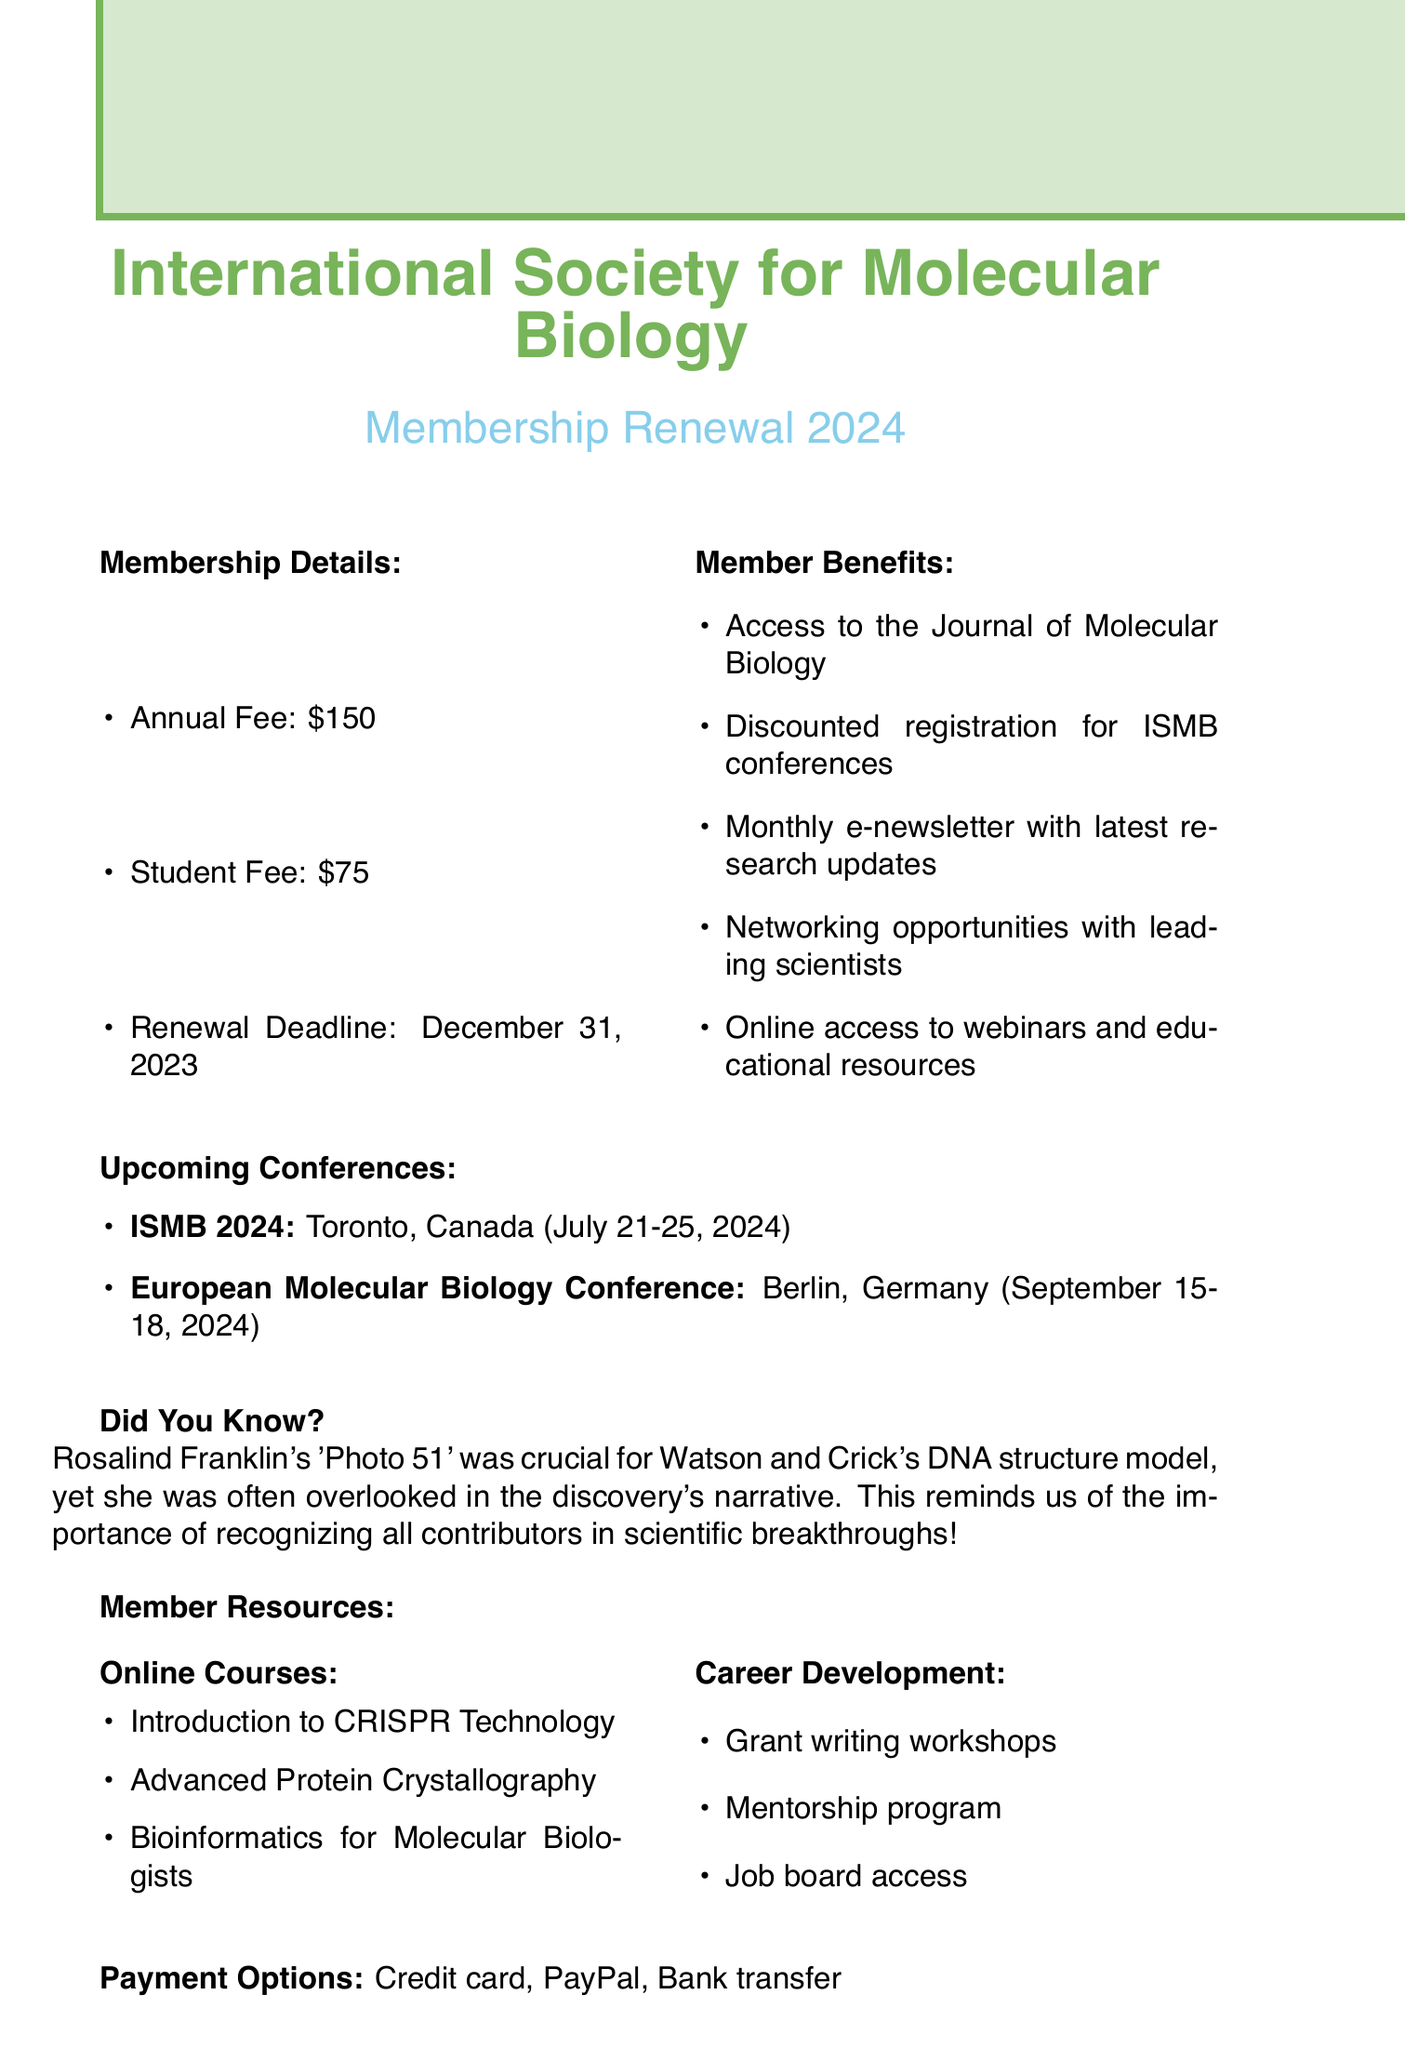What is the annual membership fee? The document states the annual fee for membership is clearly indicated in the membership details section.
Answer: $150 What is the student membership fee? The document specifies the student fee in the membership details.
Answer: $75 What is the renewal deadline for membership? The renewal deadline is explicitly mentioned in the membership details section of the document.
Answer: December 31, 2023 Who is the keynote speaker for ISMB 2024? The document includes the keynote speaker's name for the ISMB 2024 conference in the upcoming conferences section.
Answer: Dr. Jennifer Doudna Where is the European Molecular Biology Conference being held? The document provides the location for the European Molecular Biology Conference in the upcoming conferences section.
Answer: Berlin, Germany What benefit includes access to latest research updates? The document lists member benefits, and one specifically mentions access to research updates.
Answer: Monthly e-newsletter Which resource would help with grant proposals? The document describes several career development resources, one of which is focused on grant writing.
Answer: Grant writing workshops How many online courses are listed? The document lists the number of online courses available in the member resources section.
Answer: 3 What is the email contact for membership inquiries? The document provides contact information including the email address for membership inquiries.
Answer: membership@ismb.org What payment options are available? The document mentions payment options for membership renewal in a specific section.
Answer: Credit card, PayPal, Bank transfer 